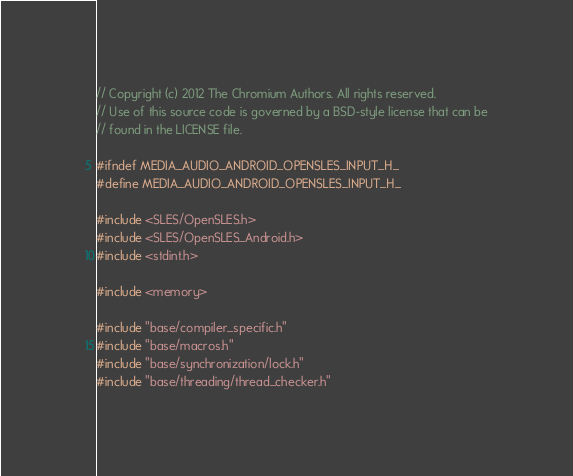<code> <loc_0><loc_0><loc_500><loc_500><_C_>// Copyright (c) 2012 The Chromium Authors. All rights reserved.
// Use of this source code is governed by a BSD-style license that can be
// found in the LICENSE file.

#ifndef MEDIA_AUDIO_ANDROID_OPENSLES_INPUT_H_
#define MEDIA_AUDIO_ANDROID_OPENSLES_INPUT_H_

#include <SLES/OpenSLES.h>
#include <SLES/OpenSLES_Android.h>
#include <stdint.h>

#include <memory>

#include "base/compiler_specific.h"
#include "base/macros.h"
#include "base/synchronization/lock.h"
#include "base/threading/thread_checker.h"</code> 